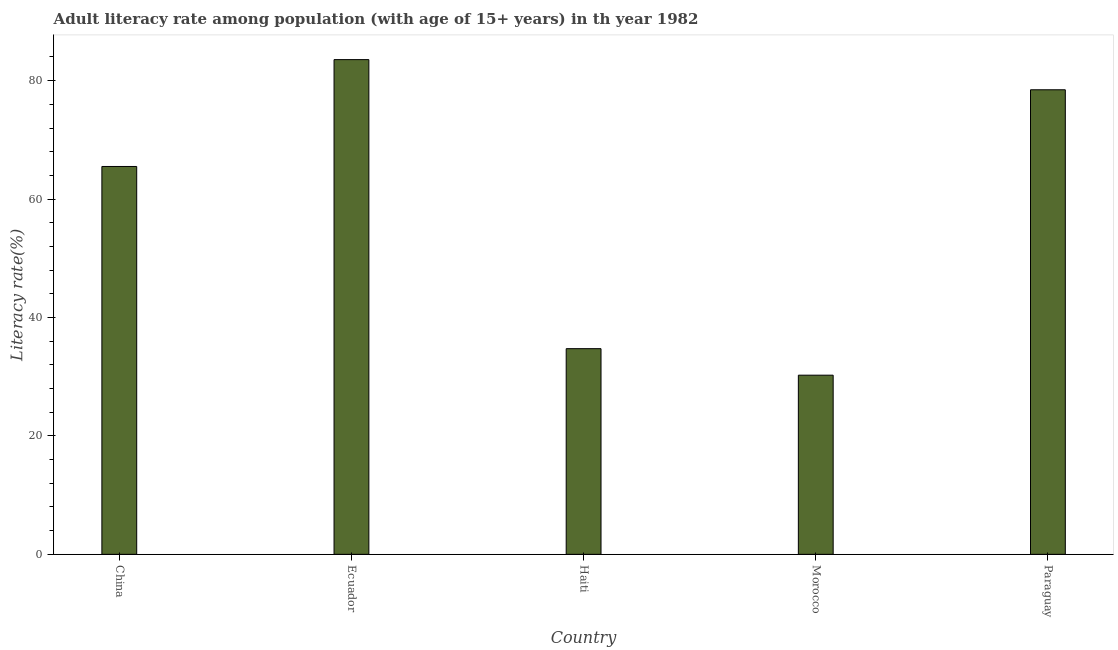Does the graph contain any zero values?
Your answer should be very brief. No. Does the graph contain grids?
Your response must be concise. No. What is the title of the graph?
Make the answer very short. Adult literacy rate among population (with age of 15+ years) in th year 1982. What is the label or title of the Y-axis?
Your answer should be compact. Literacy rate(%). What is the adult literacy rate in Morocco?
Offer a terse response. 30.26. Across all countries, what is the maximum adult literacy rate?
Offer a terse response. 83.55. Across all countries, what is the minimum adult literacy rate?
Give a very brief answer. 30.26. In which country was the adult literacy rate maximum?
Provide a short and direct response. Ecuador. In which country was the adult literacy rate minimum?
Provide a succinct answer. Morocco. What is the sum of the adult literacy rate?
Offer a very short reply. 292.51. What is the difference between the adult literacy rate in China and Paraguay?
Your answer should be very brief. -12.95. What is the average adult literacy rate per country?
Keep it short and to the point. 58.5. What is the median adult literacy rate?
Keep it short and to the point. 65.51. In how many countries, is the adult literacy rate greater than 12 %?
Your answer should be compact. 5. What is the ratio of the adult literacy rate in Haiti to that in Morocco?
Ensure brevity in your answer.  1.15. Is the adult literacy rate in China less than that in Haiti?
Offer a very short reply. No. Is the difference between the adult literacy rate in China and Morocco greater than the difference between any two countries?
Offer a terse response. No. What is the difference between the highest and the second highest adult literacy rate?
Your response must be concise. 5.09. What is the difference between the highest and the lowest adult literacy rate?
Provide a succinct answer. 53.29. In how many countries, is the adult literacy rate greater than the average adult literacy rate taken over all countries?
Give a very brief answer. 3. How many countries are there in the graph?
Your answer should be compact. 5. Are the values on the major ticks of Y-axis written in scientific E-notation?
Offer a very short reply. No. What is the Literacy rate(%) in China?
Make the answer very short. 65.51. What is the Literacy rate(%) in Ecuador?
Provide a succinct answer. 83.55. What is the Literacy rate(%) of Haiti?
Your answer should be very brief. 34.73. What is the Literacy rate(%) in Morocco?
Provide a succinct answer. 30.26. What is the Literacy rate(%) in Paraguay?
Give a very brief answer. 78.46. What is the difference between the Literacy rate(%) in China and Ecuador?
Your response must be concise. -18.05. What is the difference between the Literacy rate(%) in China and Haiti?
Keep it short and to the point. 30.77. What is the difference between the Literacy rate(%) in China and Morocco?
Your answer should be compact. 35.25. What is the difference between the Literacy rate(%) in China and Paraguay?
Your answer should be very brief. -12.95. What is the difference between the Literacy rate(%) in Ecuador and Haiti?
Provide a succinct answer. 48.82. What is the difference between the Literacy rate(%) in Ecuador and Morocco?
Keep it short and to the point. 53.29. What is the difference between the Literacy rate(%) in Ecuador and Paraguay?
Your answer should be very brief. 5.09. What is the difference between the Literacy rate(%) in Haiti and Morocco?
Offer a very short reply. 4.48. What is the difference between the Literacy rate(%) in Haiti and Paraguay?
Keep it short and to the point. -43.72. What is the difference between the Literacy rate(%) in Morocco and Paraguay?
Your response must be concise. -48.2. What is the ratio of the Literacy rate(%) in China to that in Ecuador?
Make the answer very short. 0.78. What is the ratio of the Literacy rate(%) in China to that in Haiti?
Ensure brevity in your answer.  1.89. What is the ratio of the Literacy rate(%) in China to that in Morocco?
Offer a very short reply. 2.17. What is the ratio of the Literacy rate(%) in China to that in Paraguay?
Your answer should be compact. 0.83. What is the ratio of the Literacy rate(%) in Ecuador to that in Haiti?
Offer a very short reply. 2.4. What is the ratio of the Literacy rate(%) in Ecuador to that in Morocco?
Ensure brevity in your answer.  2.76. What is the ratio of the Literacy rate(%) in Ecuador to that in Paraguay?
Your response must be concise. 1.06. What is the ratio of the Literacy rate(%) in Haiti to that in Morocco?
Ensure brevity in your answer.  1.15. What is the ratio of the Literacy rate(%) in Haiti to that in Paraguay?
Ensure brevity in your answer.  0.44. What is the ratio of the Literacy rate(%) in Morocco to that in Paraguay?
Provide a short and direct response. 0.39. 